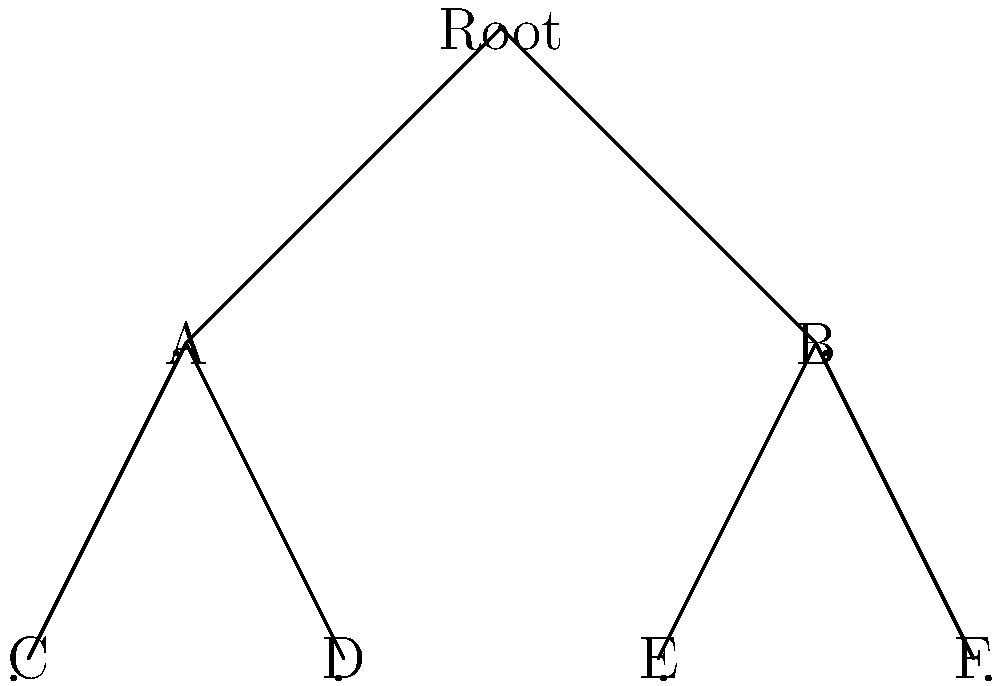In the context of secure mobile applications, you're designing a hierarchical data structure for user permissions. The tree structure above represents different levels of access. If each node stores a cryptographic key, and a user must possess keys from the root to their access level, what is the minimum number of keys required for a user with access level F? To determine the minimum number of keys required for a user with access level F, we need to trace the path from the root to node F:

1. Start at the root node (Root).
2. Move to node B (level 1).
3. Finally, reach node F (level 2).

The user needs a key for each node along this path:

1. Key for Root node
2. Key for node B
3. Key for node F

This approach, known as a hierarchical key management system, ensures that:

a) Users can access their level and all levels below them.
b) If a user's access is revoked, only their specific key needs to be changed, not the entire tree.
c) It minimizes the number of keys each user needs to store, improving efficiency and security.

Therefore, the minimum number of keys required for a user with access level F is 3.
Answer: 3 keys 